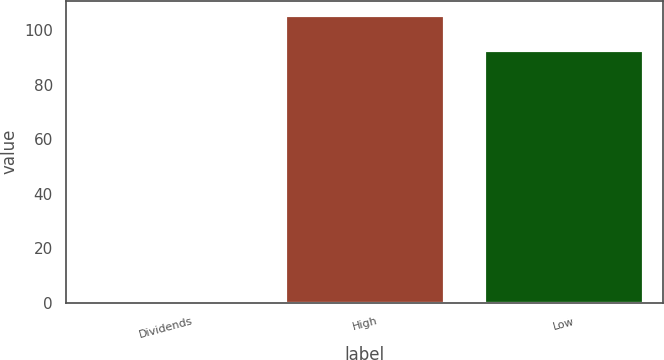Convert chart. <chart><loc_0><loc_0><loc_500><loc_500><bar_chart><fcel>Dividends<fcel>High<fcel>Low<nl><fcel>0.47<fcel>105.6<fcel>92.8<nl></chart> 